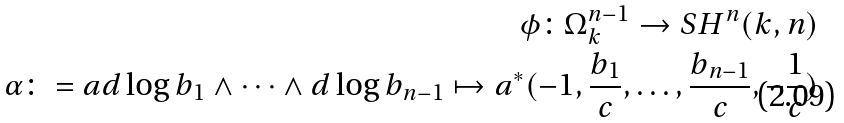<formula> <loc_0><loc_0><loc_500><loc_500>\phi \colon \Omega ^ { n - 1 } _ { k } \to S H ^ { n } ( k , n ) \\ \alpha \colon = a d \log b _ { 1 } \wedge \dots \wedge d \log b _ { n - 1 } \mapsto a ^ { * } ( - 1 , \frac { b _ { 1 } } { c } , \dots , \frac { b _ { n - 1 } } { c } , - \frac { 1 } { c } )</formula> 